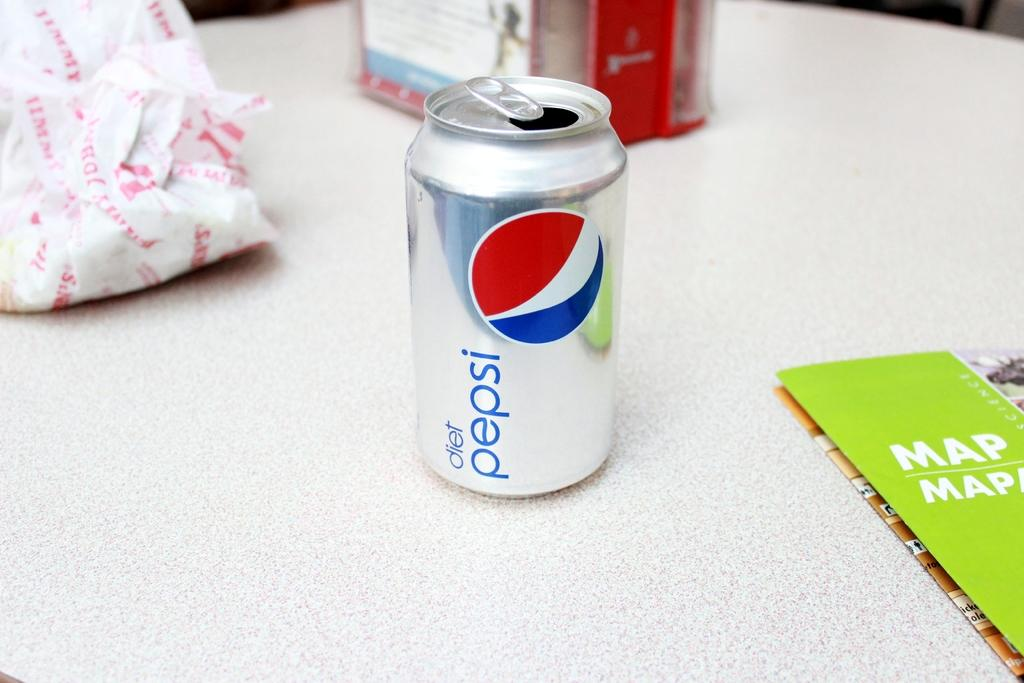<image>
Describe the image concisely. a pepsi can that is on a white surface 